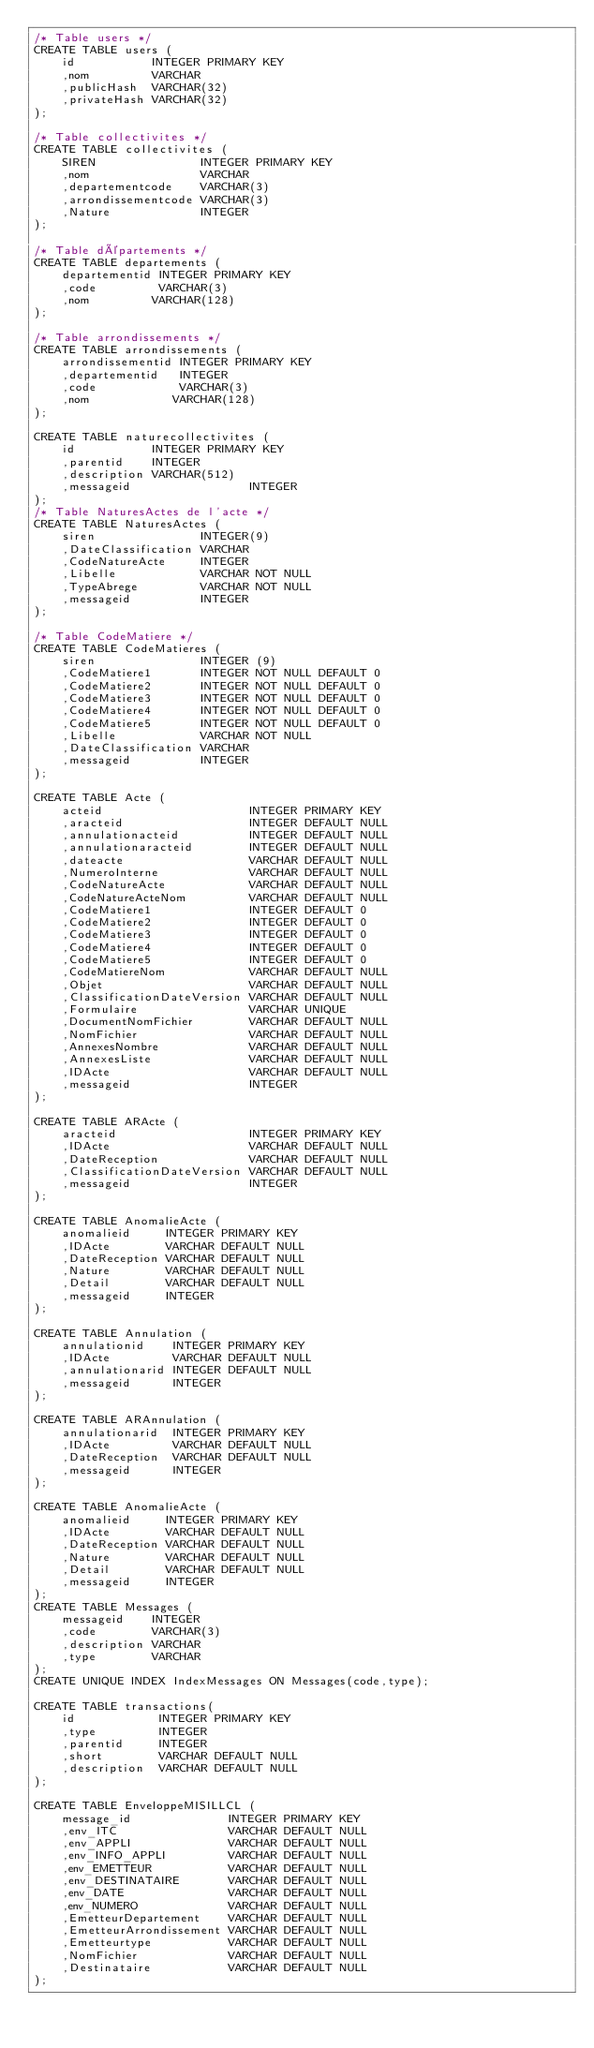<code> <loc_0><loc_0><loc_500><loc_500><_SQL_>/* Table users */
CREATE TABLE users (
    id           INTEGER PRIMARY KEY
    ,nom         VARCHAR
    ,publicHash  VARCHAR(32)
    ,privateHash VARCHAR(32)
);

/* Table collectivites */
CREATE TABLE collectivites (
    SIREN               INTEGER PRIMARY KEY
    ,nom                VARCHAR
    ,departementcode    VARCHAR(3)
    ,arrondissementcode VARCHAR(3)
    ,Nature             INTEGER
);

/* Table départements */
CREATE TABLE departements (
    departementid INTEGER PRIMARY KEY
    ,code         VARCHAR(3)
    ,nom         VARCHAR(128)
);

/* Table arrondissements */
CREATE TABLE arrondissements (
    arrondissementid INTEGER PRIMARY KEY
    ,departementid   INTEGER
    ,code            VARCHAR(3)
    ,nom            VARCHAR(128)
);

CREATE TABLE naturecollectivites (
    id           INTEGER PRIMARY KEY
    ,parentid    INTEGER
    ,description VARCHAR(512)
    ,messageid                 INTEGER
);
/* Table NaturesActes de l'acte */
CREATE TABLE NaturesActes (
    siren               INTEGER(9)
    ,DateClassification VARCHAR
    ,CodeNatureActe     INTEGER
    ,Libelle            VARCHAR NOT NULL
    ,TypeAbrege         VARCHAR NOT NULL
    ,messageid          INTEGER
);

/* Table CodeMatiere */
CREATE TABLE CodeMatieres (
    siren               INTEGER (9)
    ,CodeMatiere1       INTEGER NOT NULL DEFAULT 0
    ,CodeMatiere2       INTEGER NOT NULL DEFAULT 0
    ,CodeMatiere3       INTEGER NOT NULL DEFAULT 0
    ,CodeMatiere4       INTEGER NOT NULL DEFAULT 0
    ,CodeMatiere5       INTEGER NOT NULL DEFAULT 0
    ,Libelle            VARCHAR NOT NULL
    ,DateClassification VARCHAR
    ,messageid          INTEGER
);

CREATE TABLE Acte (
    acteid                     INTEGER PRIMARY KEY
    ,aracteid                  INTEGER DEFAULT NULL
    ,annulationacteid          INTEGER DEFAULT NULL
    ,annulationaracteid        INTEGER DEFAULT NULL
    ,dateacte                  VARCHAR DEFAULT NULL
    ,NumeroInterne             VARCHAR DEFAULT NULL
    ,CodeNatureActe            VARCHAR DEFAULT NULL
    ,CodeNatureActeNom         VARCHAR DEFAULT NULL
    ,CodeMatiere1              INTEGER DEFAULT 0
    ,CodeMatiere2              INTEGER DEFAULT 0
    ,CodeMatiere3              INTEGER DEFAULT 0
    ,CodeMatiere4              INTEGER DEFAULT 0
    ,CodeMatiere5              INTEGER DEFAULT 0
    ,CodeMatiereNom            VARCHAR DEFAULT NULL
    ,Objet                     VARCHAR DEFAULT NULL
    ,ClassificationDateVersion VARCHAR DEFAULT NULL
    ,Formulaire                VARCHAR UNIQUE
    ,DocumentNomFichier        VARCHAR DEFAULT NULL
    ,NomFichier                VARCHAR DEFAULT NULL
    ,AnnexesNombre             VARCHAR DEFAULT NULL
    ,AnnexesListe              VARCHAR DEFAULT NULL
    ,IDActe                    VARCHAR DEFAULT NULL
    ,messageid                 INTEGER
);

CREATE TABLE ARActe (
    aracteid                   INTEGER PRIMARY KEY
    ,IDActe                    VARCHAR DEFAULT NULL
    ,DateReception             VARCHAR DEFAULT NULL
    ,ClassificationDateVersion VARCHAR DEFAULT NULL
    ,messageid                 INTEGER
);

CREATE TABLE AnomalieActe (
    anomalieid     INTEGER PRIMARY KEY
    ,IDActe        VARCHAR DEFAULT NULL
    ,DateReception VARCHAR DEFAULT NULL
    ,Nature        VARCHAR DEFAULT NULL
    ,Detail        VARCHAR DEFAULT NULL
    ,messageid     INTEGER
);

CREATE TABLE Annulation (
    annulationid    INTEGER PRIMARY KEY
    ,IDActe         VARCHAR DEFAULT NULL
    ,annulationarid INTEGER DEFAULT NULL
    ,messageid      INTEGER
);

CREATE TABLE ARAnnulation (
    annulationarid  INTEGER PRIMARY KEY
    ,IDActe         VARCHAR DEFAULT NULL
    ,DateReception  VARCHAR DEFAULT NULL
    ,messageid      INTEGER
);

CREATE TABLE AnomalieActe (
    anomalieid     INTEGER PRIMARY KEY
    ,IDActe        VARCHAR DEFAULT NULL
    ,DateReception VARCHAR DEFAULT NULL
    ,Nature        VARCHAR DEFAULT NULL
    ,Detail        VARCHAR DEFAULT NULL
    ,messageid     INTEGER
);
CREATE TABLE Messages (
    messageid    INTEGER
    ,code        VARCHAR(3)
    ,description VARCHAR
    ,type        VARCHAR
);
CREATE UNIQUE INDEX IndexMessages ON Messages(code,type);

CREATE TABLE transactions(
    id            INTEGER PRIMARY KEY
    ,type         INTEGER
    ,parentid     INTEGER
    ,short        VARCHAR DEFAULT NULL
    ,description  VARCHAR DEFAULT NULL
);

CREATE TABLE EnveloppeMISILLCL (
    message_id              INTEGER PRIMARY KEY
    ,env_ITC                VARCHAR DEFAULT NULL
    ,env_APPLI              VARCHAR DEFAULT NULL
    ,env_INFO_APPLI         VARCHAR DEFAULT NULL
    ,env_EMETTEUR           VARCHAR DEFAULT NULL
    ,env_DESTINATAIRE       VARCHAR DEFAULT NULL
    ,env_DATE               VARCHAR DEFAULT NULL
    ,env_NUMERO             VARCHAR DEFAULT NULL
    ,EmetteurDepartement    VARCHAR DEFAULT NULL
    ,EmetteurArrondissement VARCHAR DEFAULT NULL
    ,Emetteurtype           VARCHAR DEFAULT NULL
    ,NomFichier             VARCHAR DEFAULT NULL
    ,Destinataire           VARCHAR DEFAULT NULL
);</code> 